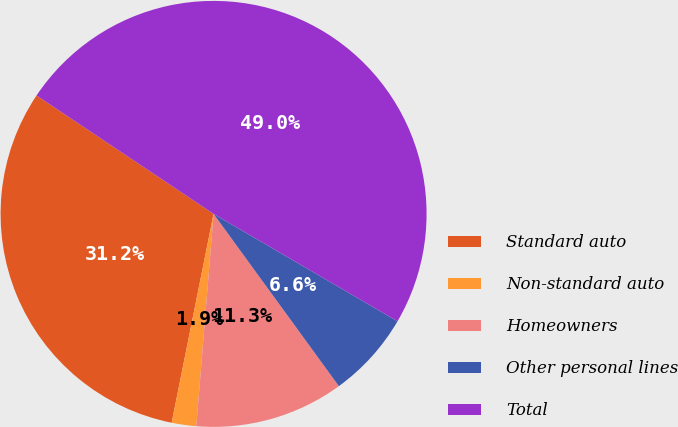<chart> <loc_0><loc_0><loc_500><loc_500><pie_chart><fcel>Standard auto<fcel>Non-standard auto<fcel>Homeowners<fcel>Other personal lines<fcel>Total<nl><fcel>31.23%<fcel>1.86%<fcel>11.3%<fcel>6.58%<fcel>49.03%<nl></chart> 